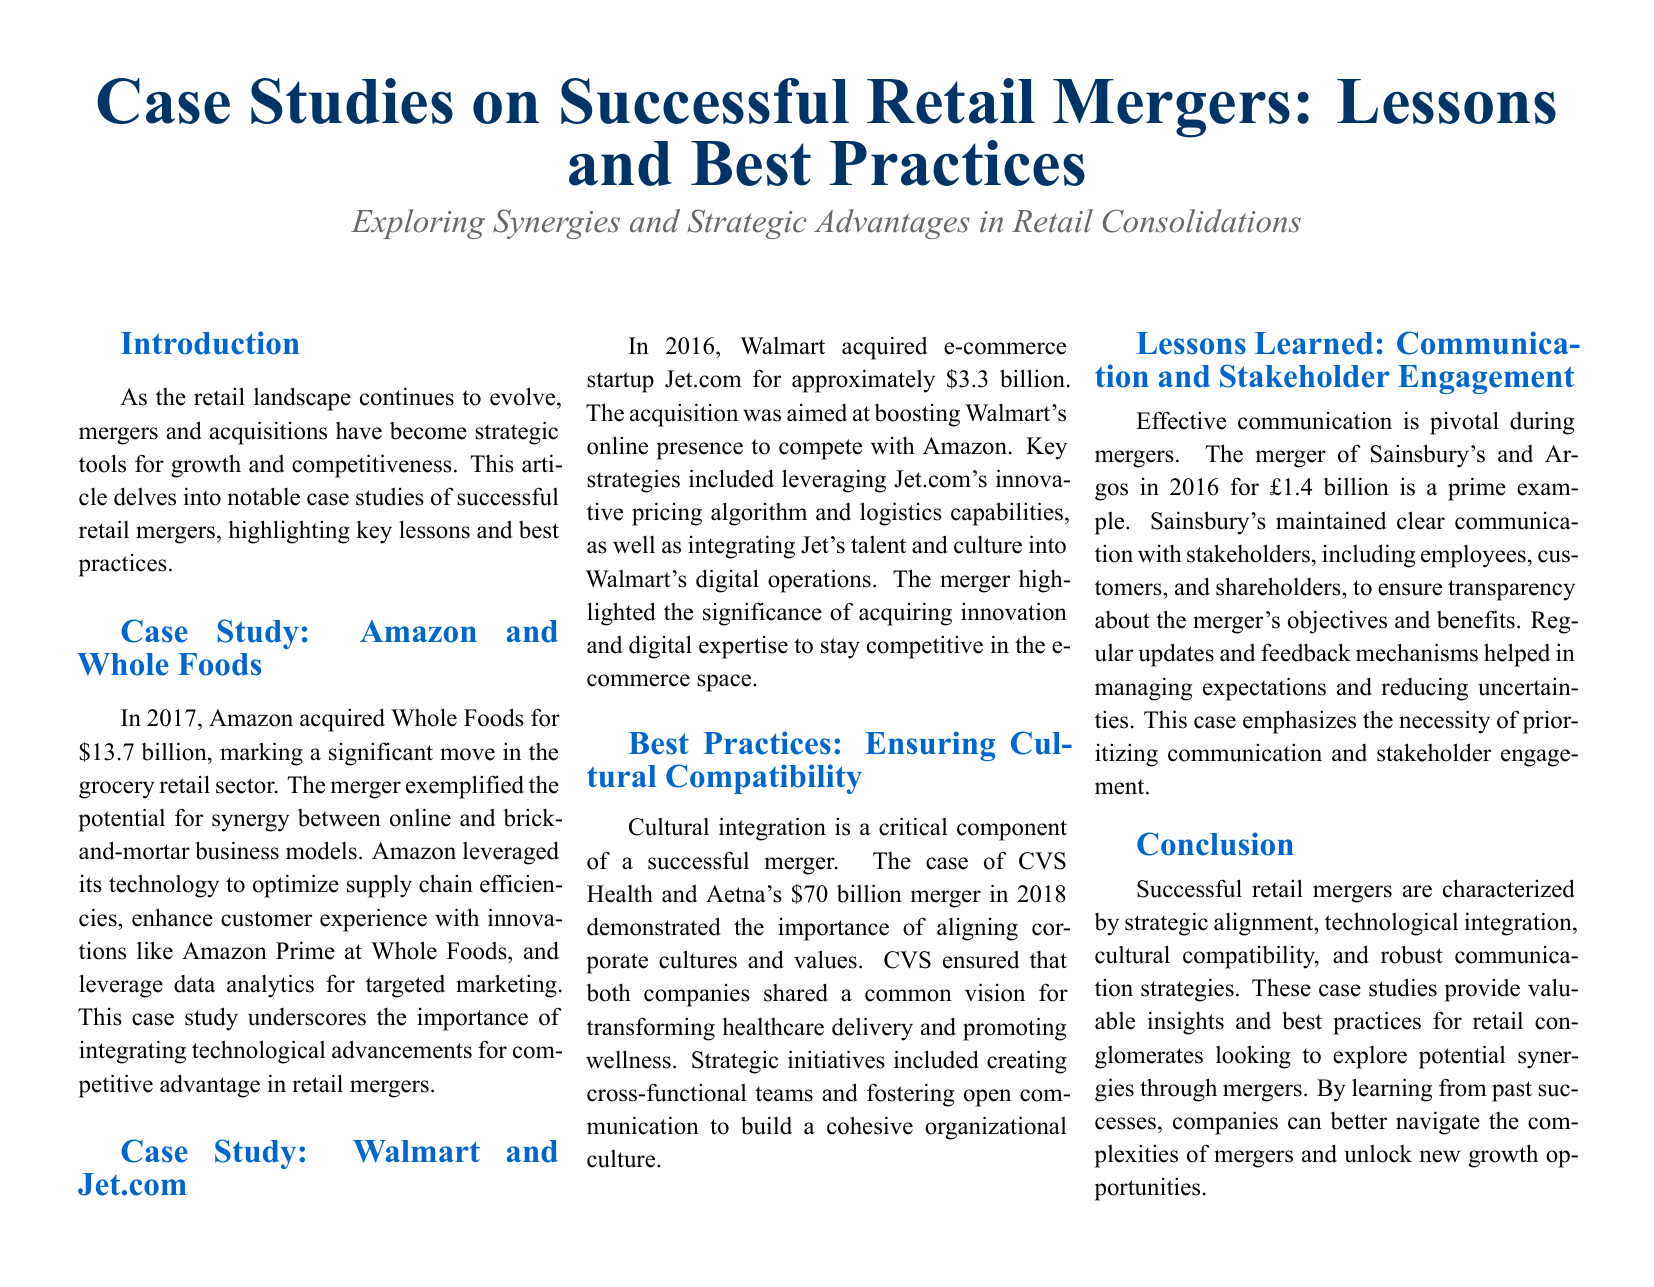What year did Amazon acquire Whole Foods? The document states that Amazon acquired Whole Foods in 2017.
Answer: 2017 What was the acquisition cost of Walmart's purchase of Jet.com? The document mentions that Walmart acquired Jet.com for approximately 3.3 billion dollars.
Answer: 3.3 billion Which two companies merged in a deal worth 70 billion dollars? CVS Health and Aetna merged for 70 billion dollars according to the document.
Answer: CVS Health and Aetna What major advantage did Amazon leverage from its merger with Whole Foods? According to the case study, Amazon leveraged technology to optimize supply chain efficiencies.
Answer: Technology to optimize supply chain efficiencies What is emphasized as crucial during mergers according to the case study of Sainsbury's and Argos? The document emphasizes the necessity of prioritizing communication and stakeholder engagement.
Answer: Communication and stakeholder engagement 